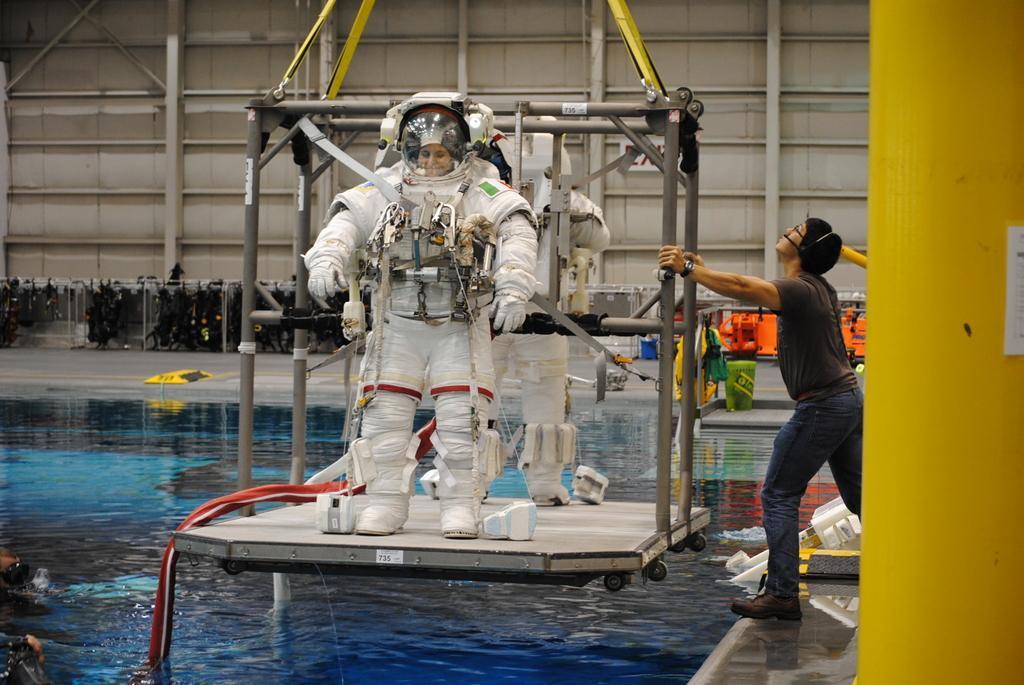Can you describe this image briefly? In this image, we can see a few people. Among them, some people are wearing costumes and standing on an object. We can see some water with some objects. We can see the ground with some objects. We can also see a yellow colored object on the right. We can see the metal wall. We can see some metal objects. 